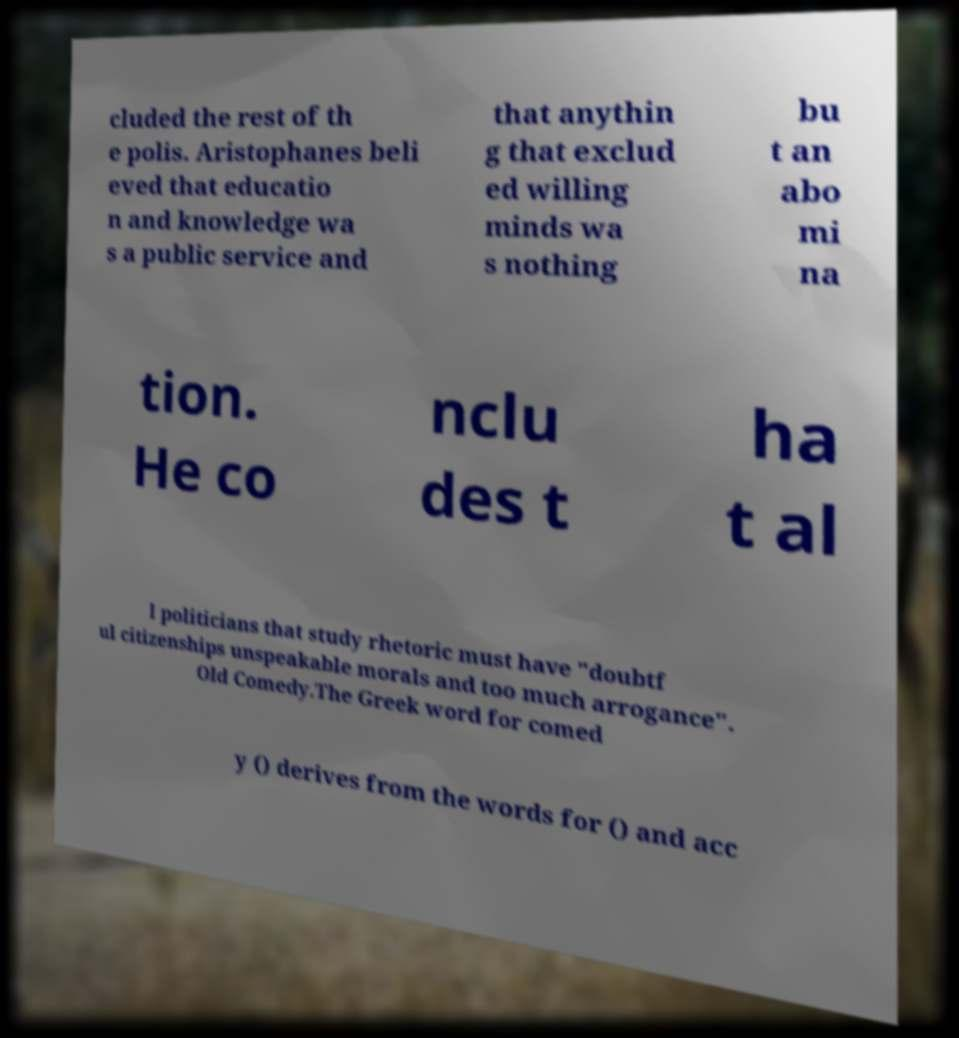Please read and relay the text visible in this image. What does it say? cluded the rest of th e polis. Aristophanes beli eved that educatio n and knowledge wa s a public service and that anythin g that exclud ed willing minds wa s nothing bu t an abo mi na tion. He co nclu des t ha t al l politicians that study rhetoric must have "doubtf ul citizenships unspeakable morals and too much arrogance". Old Comedy.The Greek word for comed y () derives from the words for () and acc 